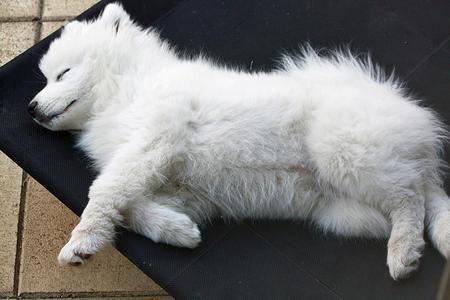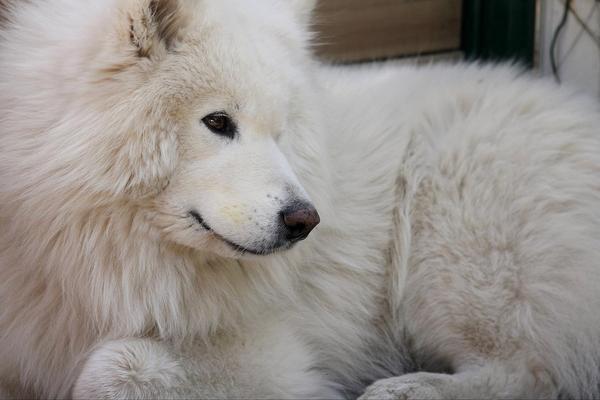The first image is the image on the left, the second image is the image on the right. Considering the images on both sides, is "The single white dog in the image on the right has its eyes open." valid? Answer yes or no. Yes. The first image is the image on the left, the second image is the image on the right. Analyze the images presented: Is the assertion "One image features a reclining white dog with opened eyes." valid? Answer yes or no. Yes. 